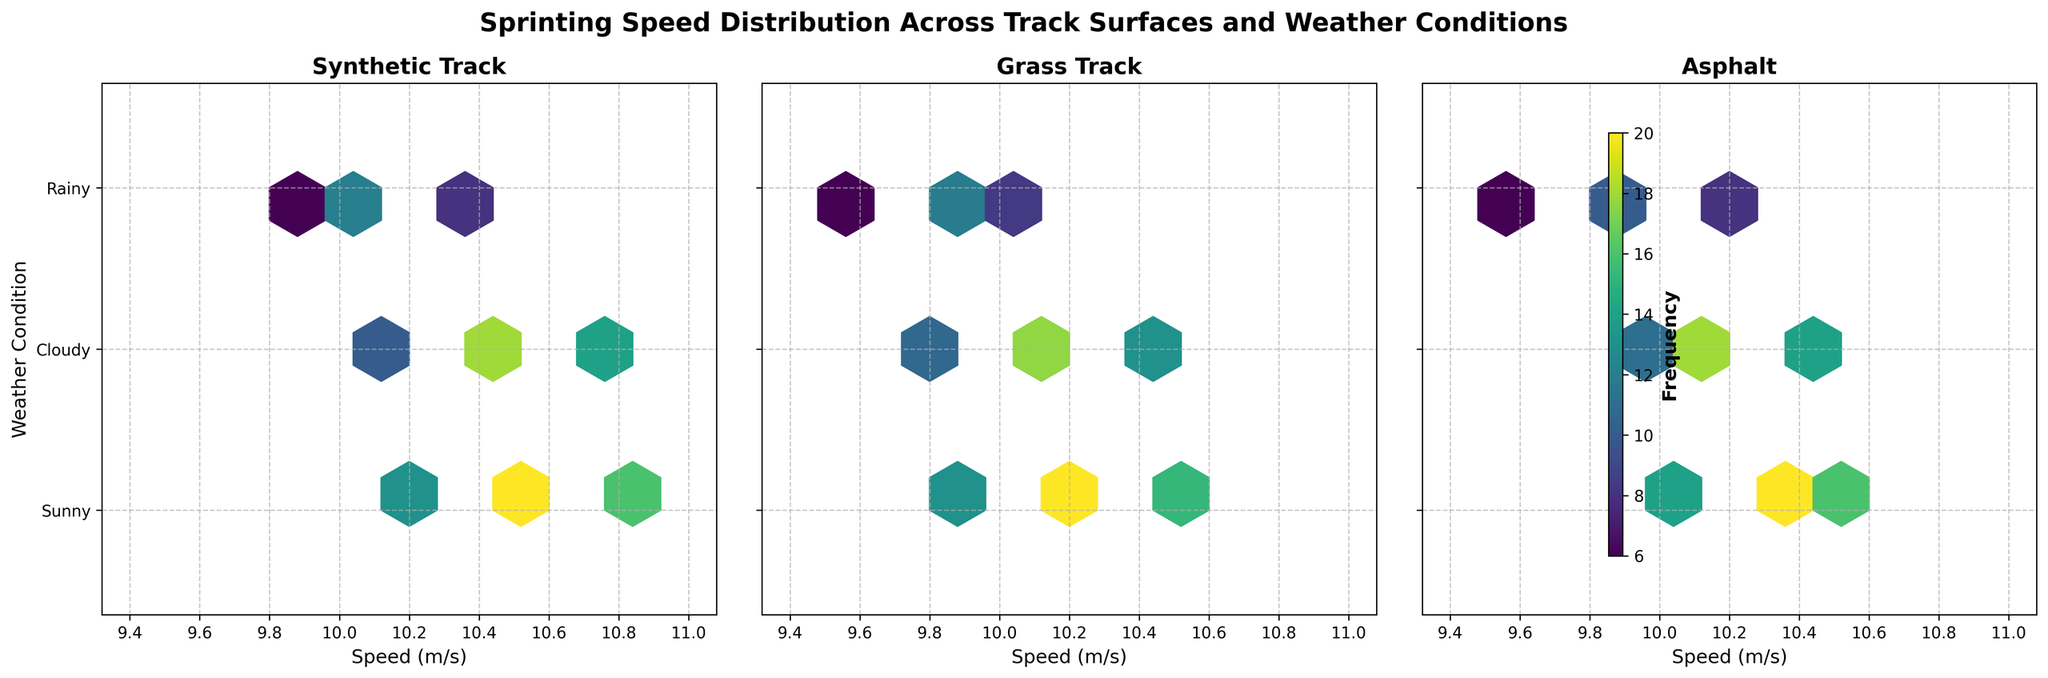What is the title of the plot? The title is located at the top center of the plot, written in bold font. It is: "Sprinting Speed Distribution Across Track Surfaces and Weather Conditions"
Answer: Sprinting Speed Distribution Across Track Surfaces and Weather Conditions How many surfaces are compared in the figure? You can see the plot has three subplots, each with a title indicating the type of surface. Therefore, the surfaces compared are "Synthetic Track," "Grass Track," and "Asphalt".
Answer: 3 Which track surface shows the highest frequency of sprints in sunny weather? By comparing the hexbin density (color intensity) within the "Sunny" weather condition (indicated by y-axis label for "Sunny") across the three surfaces, the highest density can be seen in the subplot for "Synthetic Track".
Answer: Synthetic Track Which track surface has the widest range of speeds recorded in rainy weather? Looking across the "Rainy" condition on the y-axis, we compare the hexbin spread horizontally. The "Synthetic Track" subplot shows the speeds ranging from 9.8 to 10.4 m/s, while "Grass Track" ranges from 9.5 to 10.1 m/s, and "Asphalt" ranges from 9.6 to 10.2 m/s. The "Synthetic Track" has the widest range.
Answer: Synthetic Track What speed corresponds to the highest frequency on the Grass Track in cloudy weather? Observe the hexbin plot for "Grass Track" under the "Cloudy" weather condition. The highest frequency hexbin (darkest) corresponds horizontally to a speed of 10.1 m/s.
Answer: 10.1 m/s Which weather condition generally shows the lowest sprinting speeds? By examining the y-axis for each subplot, we can observe that the "Rainy" condition shows lower speeds across all track surfaces when compared to "Sunny" and "Cloudy" conditions.
Answer: Rainy Are there more sprints recorded in sunny conditions on the Asphalt track or the Grass track? Compare the hexbin density (color intensity) within the "Sunny" weather condition across the "Asphalt" and "Grass Track" subplots. The "Asphalt" subplot shows higher intensity colors (indicating more sprints) for sunny conditions.
Answer: Asphalt Is the frequency distribution of speeds on the Synthetic Track balanced across different weather conditions? By looking at the "Synthetic Track" subplot and comparing the color intensity among the hexagons for "Sunny," "Cloudy," and "Rainy" conditions, you can see that sunny and cloudy conditions have higher and more evenly distributed frequencies than the rainy condition, which has fewer frequencies overall. This shows that it is not balanced.
Answer: No Which weather condition on the Grass Track displays the most variable sprinting speeds? Check the hexbin spread horizontally for each weather condition under the Grass Track subplot. "Sunny" shows the speeds ranging from 9.9 to 10.5 m/s, "Cloudy" from 9.8 to 10.4 m/s, and "Rainy" from 9.5 to 10.1 m/s. Thus, "Sunny" exhibits the most variability.
Answer: Sunny 